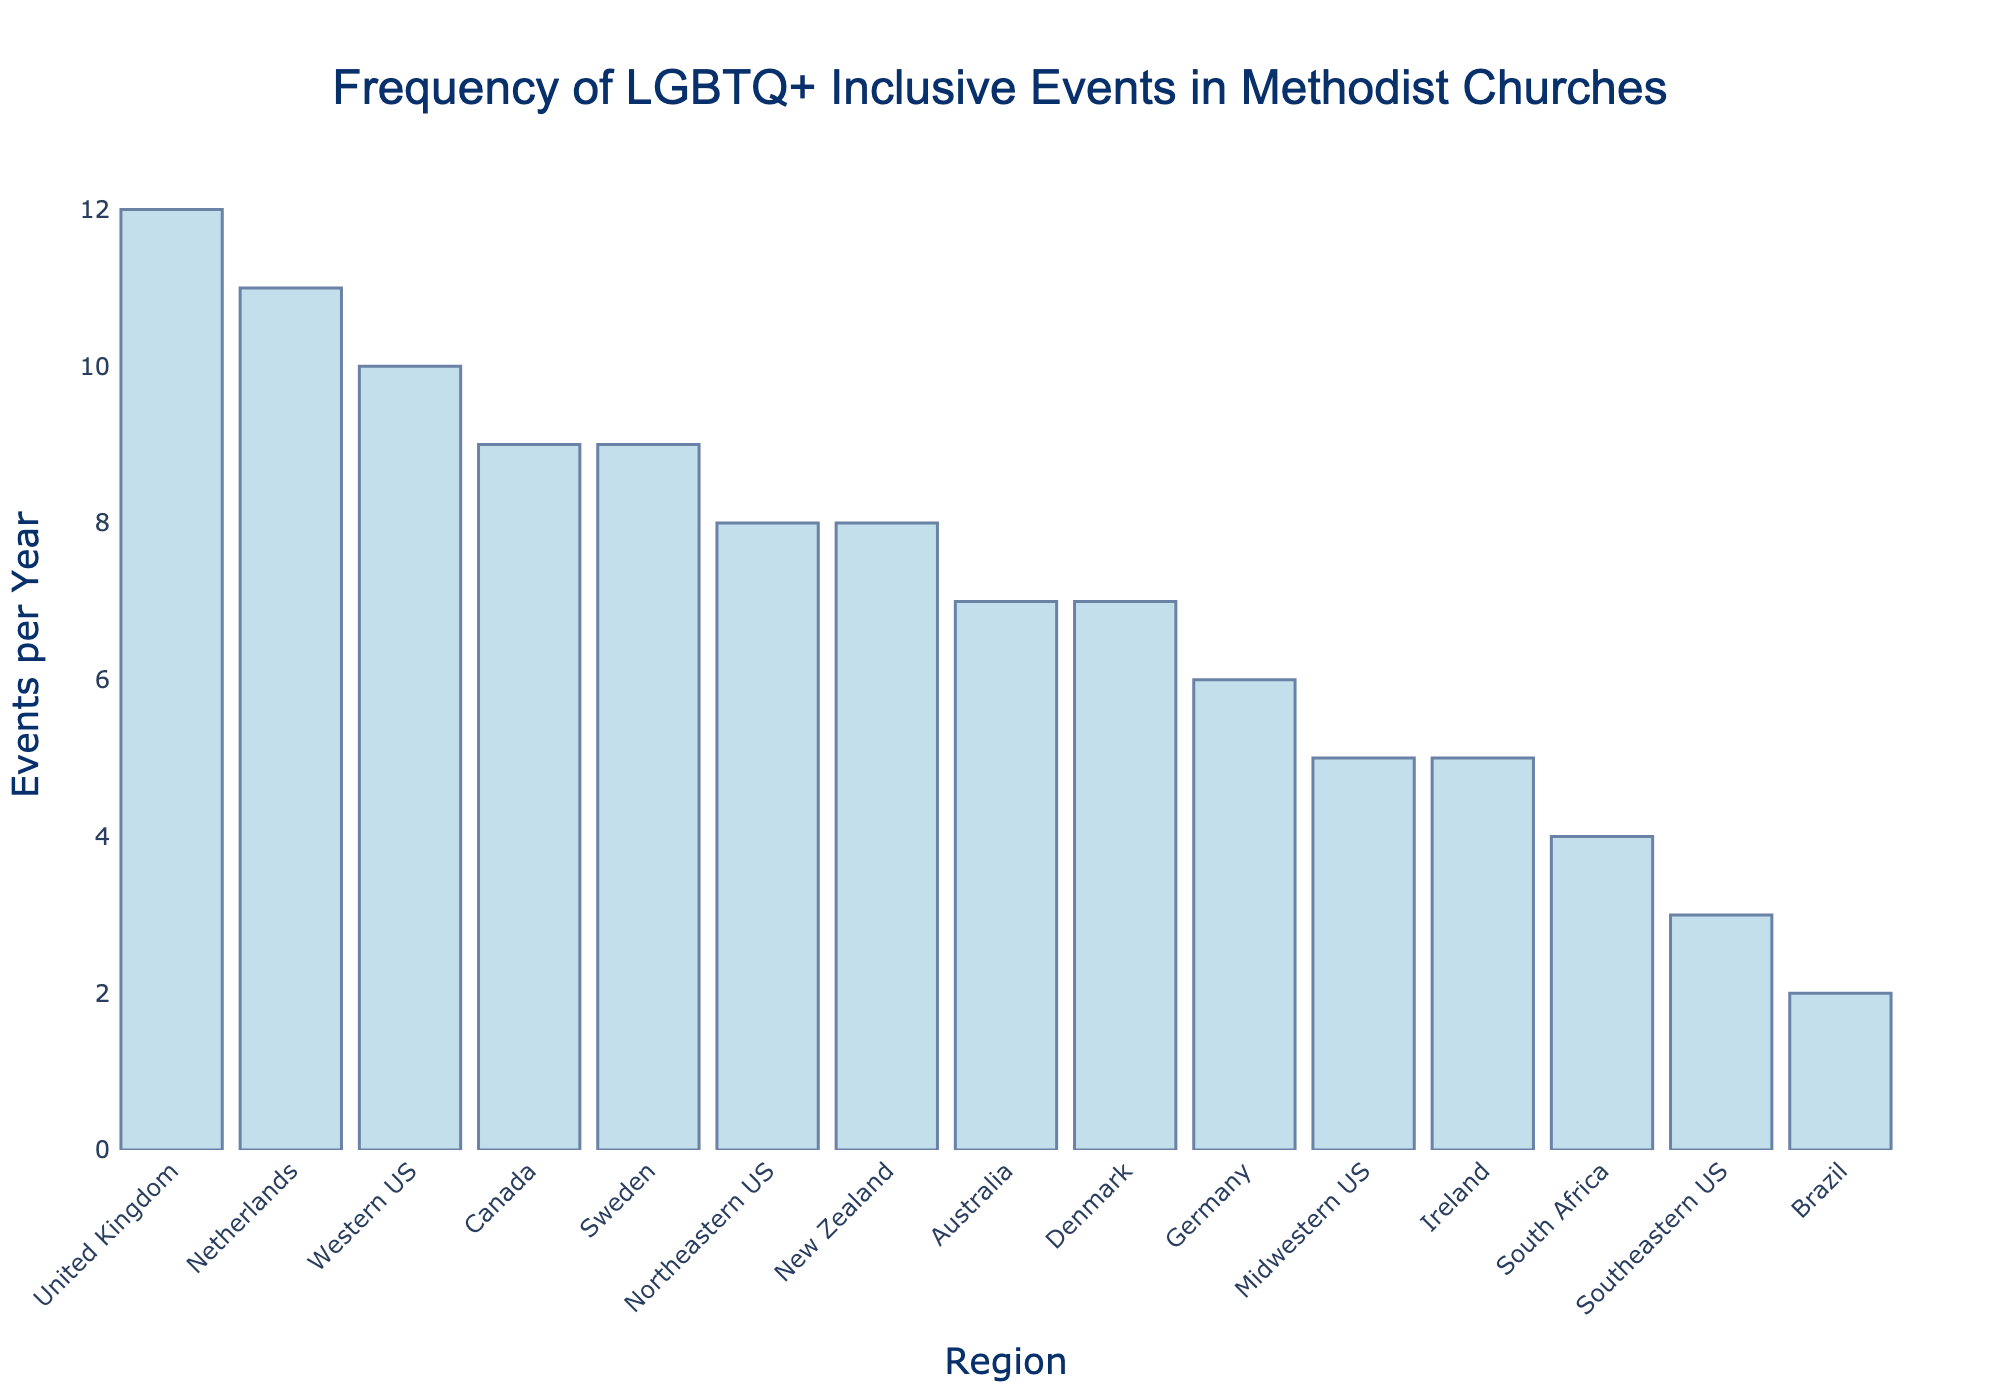Which region has the highest frequency of LGBTQ+ inclusive events per year? By observing the height of the bars, we can see that the United Kingdom has the tallest bar, indicating the highest frequency.
Answer: United Kingdom What is the difference in the number of LGBTQ+ inclusive events per year between the region with the most and the region with the least events? The United Kingdom has the most events (12), while Brazil has the least (2). The difference is 12 - 2 = 10.
Answer: 10 Which regions host more LGBTQ+ inclusive events per year than the Midwestern US? The Midwestern US hosts 5 events per year. The regions with higher values are Northeastern US (8), Western US (10), United Kingdom (12), Australia (7), Canada (9), Germany (6), Netherlands (11), Sweden (9), Denmark (7), and New Zealand (8).
Answer: Northeastern US, Western US, United Kingdom, Australia, Canada, Germany, Netherlands, Sweden, Denmark, New Zealand How many regions host exactly 9 LGBTQ+ inclusive events per year? By counting the bars with a height indicating 9 events, we find Canada and Sweden. Thus, there are 2 regions.
Answer: 2 What is the total number of LGBTQ+ inclusive events held per year in all regions depicted in the chart? Sum all the frequencies: 8 + 3 + 5 + 10 + 12 + 7 + 9 + 6 + 4 + 2 + 8 + 5 + 11 + 9 + 7 = 106.
Answer: 106 Which three regions show the closest values in terms of the frequency of LGBTQ+ inclusive events per year, and what are those values? Upon inspecting the chart, Sweden, Canada, and New Zealand all host 9 events per year, showing close values.
Answer: Sweden, Canada, New Zealand (9 events each) What is the average frequency of LGBTQ+ inclusive events per year across all regions? Divide the total number of events (106) by the number of regions (15): 106 / 15 ≈ 7.07.
Answer: 7.07 Does the Western US host more or fewer LGBTQ+ inclusive events compared to the Midwestern US and Southeastern US combined? The Western US hosts 10 events. Midwestern US (5) + Southeastern US (3) = 8. Therefore, 10 is more than 8.
Answer: More 